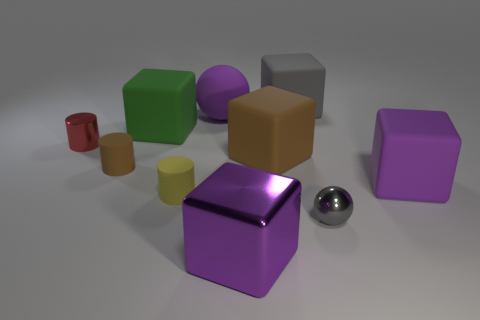What is the size of the block that is both behind the big brown rubber cube and right of the large green matte thing?
Offer a terse response. Large. How many purple balls are the same size as the gray metallic thing?
Your answer should be very brief. 0. How many metallic things are big gray objects or large balls?
Offer a very short reply. 0. What material is the big purple thing in front of the purple matte cube that is in front of the big matte ball?
Keep it short and to the point. Metal. How many things are purple matte cubes or shiny things in front of the tiny shiny ball?
Your answer should be compact. 2. There is a purple cube that is the same material as the green object; what size is it?
Provide a short and direct response. Large. What number of brown things are either small metal objects or large balls?
Provide a succinct answer. 0. The large object that is the same color as the small shiny sphere is what shape?
Give a very brief answer. Cube. Is the shape of the purple matte thing that is left of the large brown rubber cube the same as the gray thing that is in front of the big rubber sphere?
Ensure brevity in your answer.  Yes. What number of brown cylinders are there?
Provide a short and direct response. 1. 